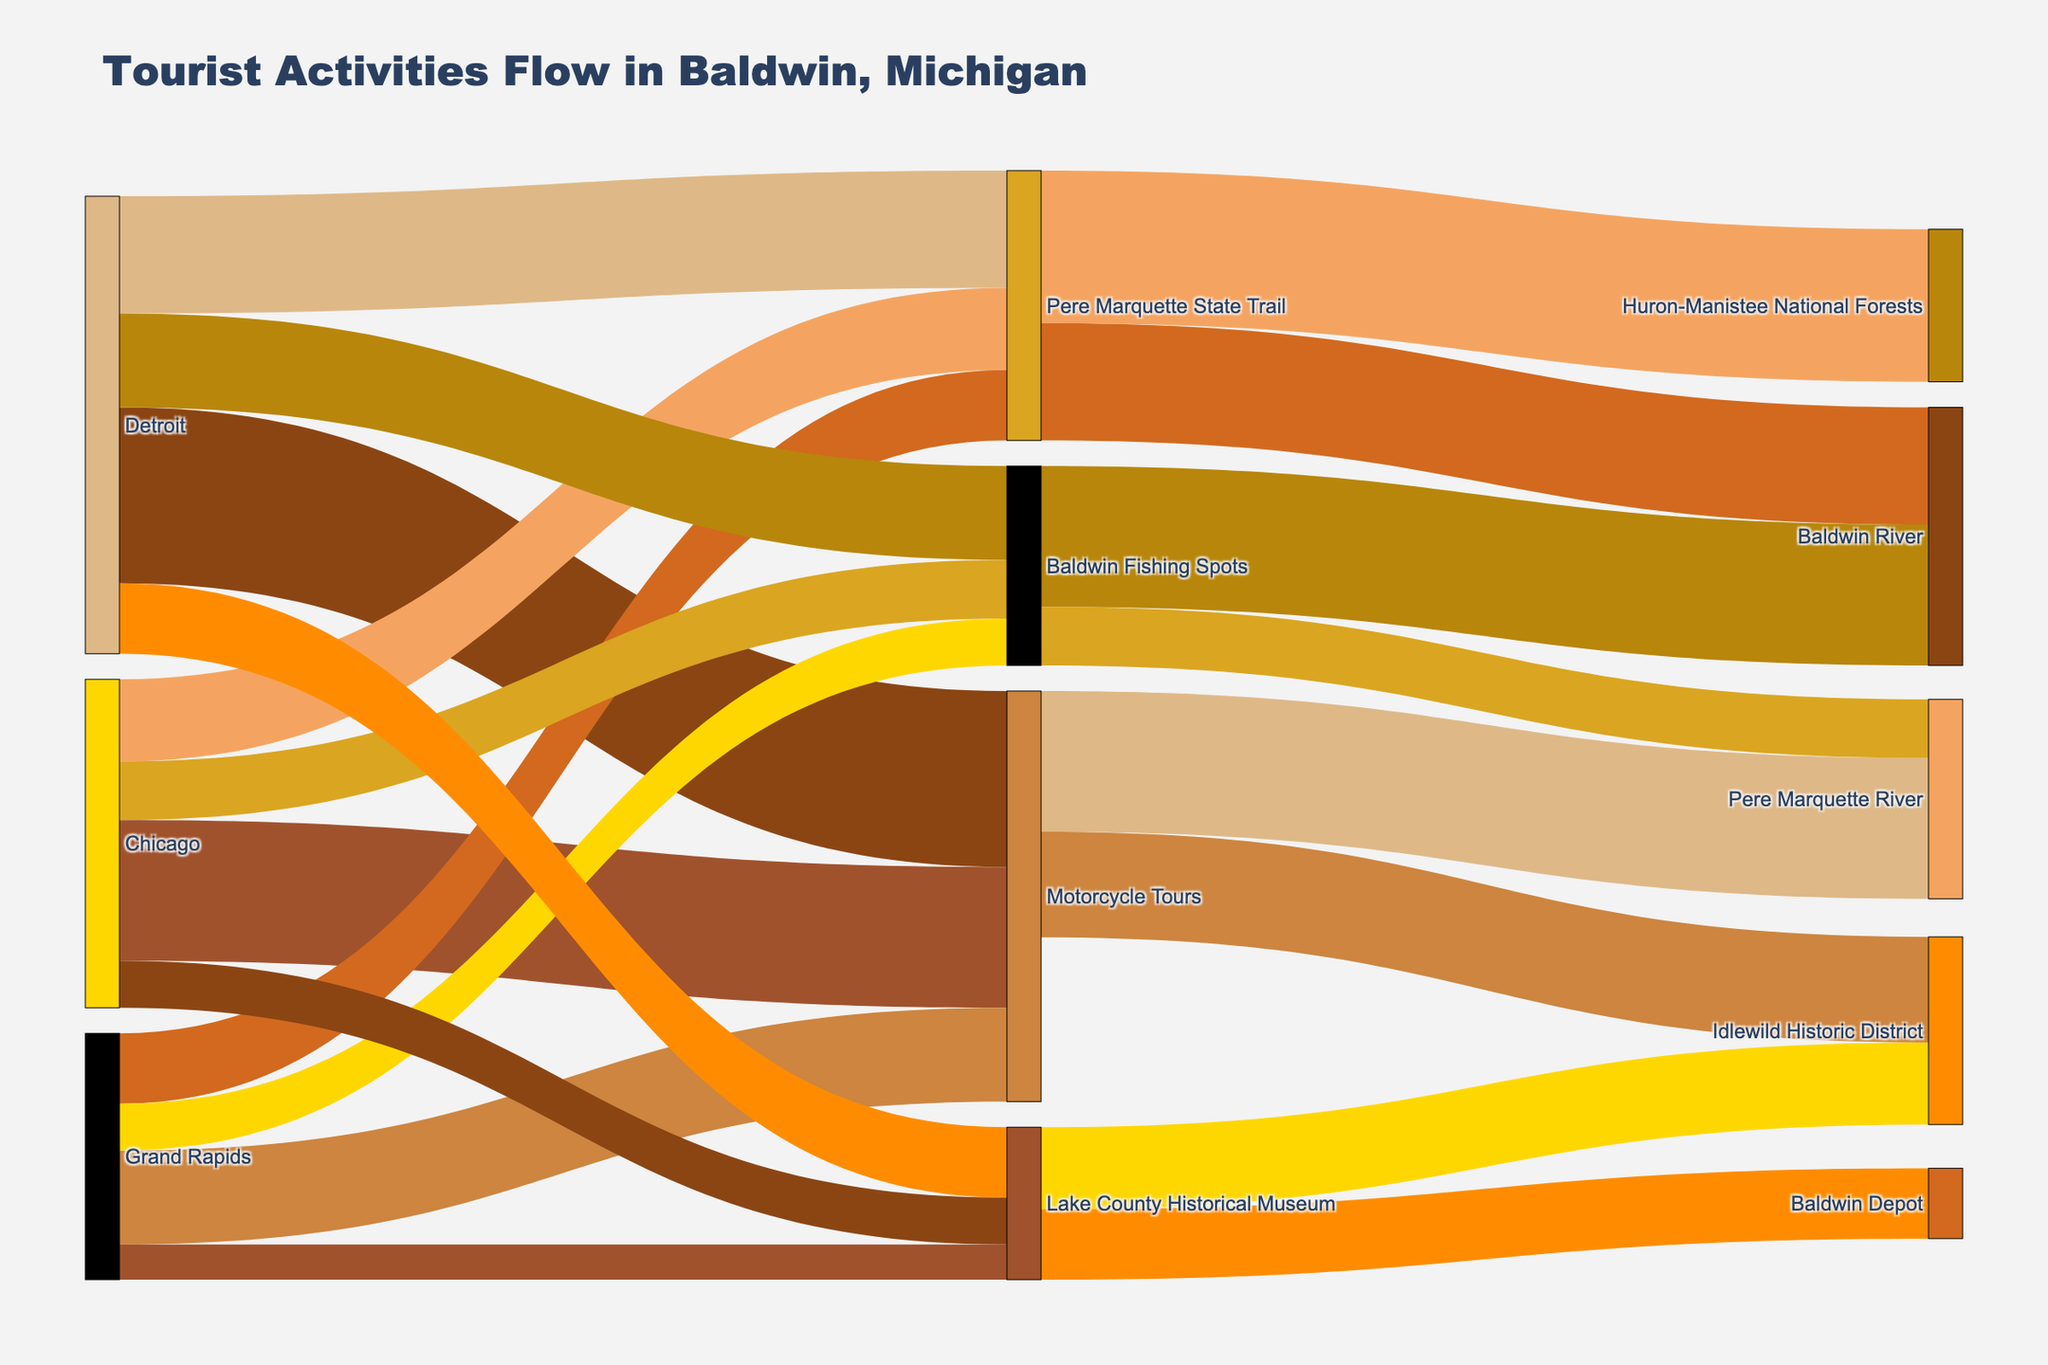How many tourists from Detroit chose Baldwin Fishing Spots? Look at the flow from Detroit to Baldwin Fishing Spots, which is represented by a link. The value associated with this link is 80.
Answer: 80 Which origin city contributed the most tourists to the Pere Marquette State Trail? Compare the values of the links from Detroit, Chicago, and Grand Rapids to the Pere Marquette State Trail. Detroit has the largest value at 100.
Answer: Detroit What attraction received the highest number of tourists from Motorcycle Tours? Observe the flows originating from Motorcycle Tours. The Pere Marquette River received the highest number with a value of 120.
Answer: Pere Marquette River What is the total number of tourists visiting Idlewild Historic District from all sources? Idlewild Historic District has links from Motorcycle Tours and the Lake County Historical Museum. The values are 90 and 70 respectively, summing to 160.
Answer: 160 Which tourist activity has the smallest number of tourists from Grand Rapids? Compare the values of the flows from Grand Rapids. Lake County Historical Museum has the smallest value of 30.
Answer: Lake County Historical Museum How many tourists visited Baldwin River combining all sources? Add the values of the links leading to Baldwin River from Pere Marquette State Trail and Baldwin Fishing Spots, which are 100 and 120 respectively, giving a total of 220.
Answer: 220 What is the total number of tourists visiting the Pere Marquette River from all sources? Pere Marquette River has flows from Motorcycle Tours and Baldwin Fishing Spots. Their values are 120 and 50 respectively, giving a total of 170.
Answer: 170 Which attraction did not receive any direct tourists from Chicago? Analyze the direct flows from Chicago. Motorcycle Tours, Pere Marquette State Trail, Baldwin Fishing Spots, and Lake County Historical Museum all have direct tourists from Chicago. All attractions are connected.
Answer: None What is the ratio of tourists from Detroit participating in Motorcycle Tours compared to those from Grand Rapids? The link from Detroit to Motorcycle Tours has 150 tourists, and Grand Rapids to Motorcycle Tours has 80. The ratio is 150/80, which simplifies to 15/8 or approximately 1.88.
Answer: 1.88 What is the combined number of tourists visiting Baldwin Fishing Spots and Lake County Historical Museum from Chicago? The values of the links from Chicago are 50 for Baldwin Fishing Spots and 40 for Lake County Historical Museum. Summing them, we get 90.
Answer: 90 